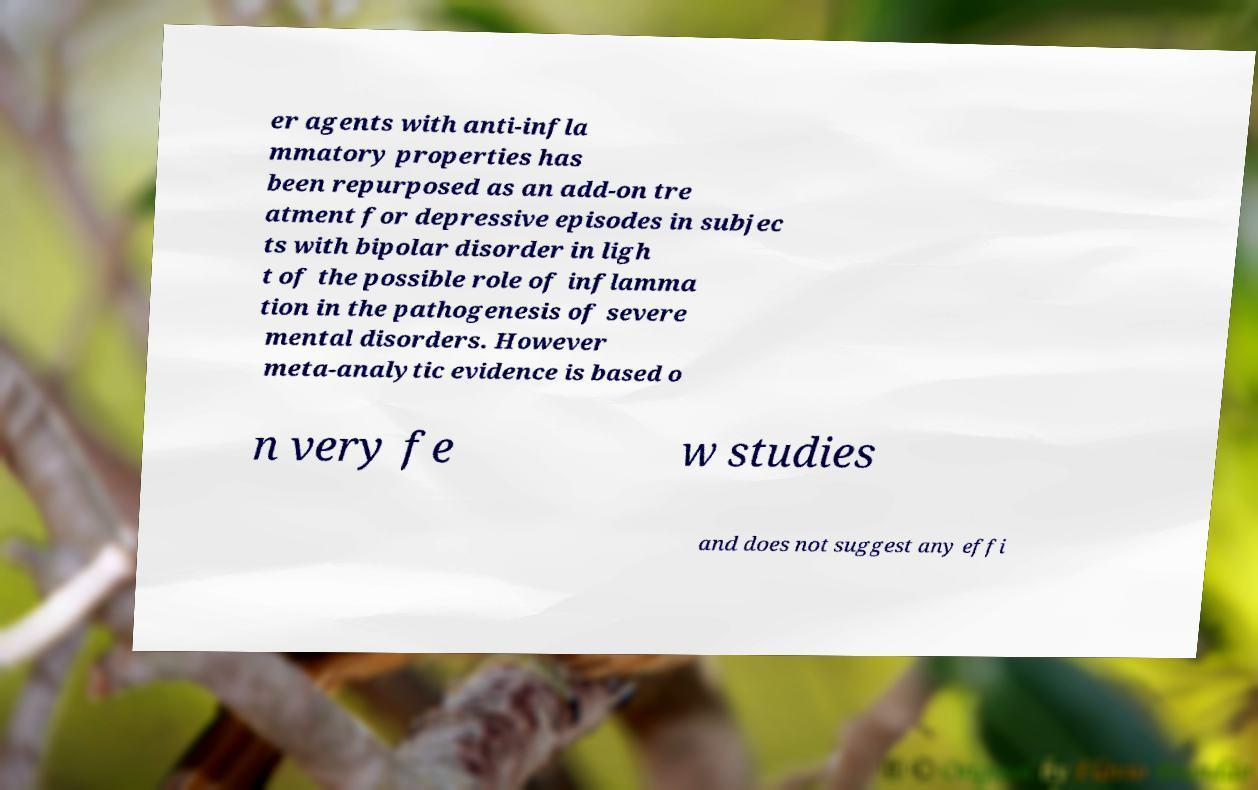Please read and relay the text visible in this image. What does it say? er agents with anti-infla mmatory properties has been repurposed as an add-on tre atment for depressive episodes in subjec ts with bipolar disorder in ligh t of the possible role of inflamma tion in the pathogenesis of severe mental disorders. However meta-analytic evidence is based o n very fe w studies and does not suggest any effi 